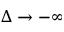<formula> <loc_0><loc_0><loc_500><loc_500>\Delta \rightarrow - \infty</formula> 